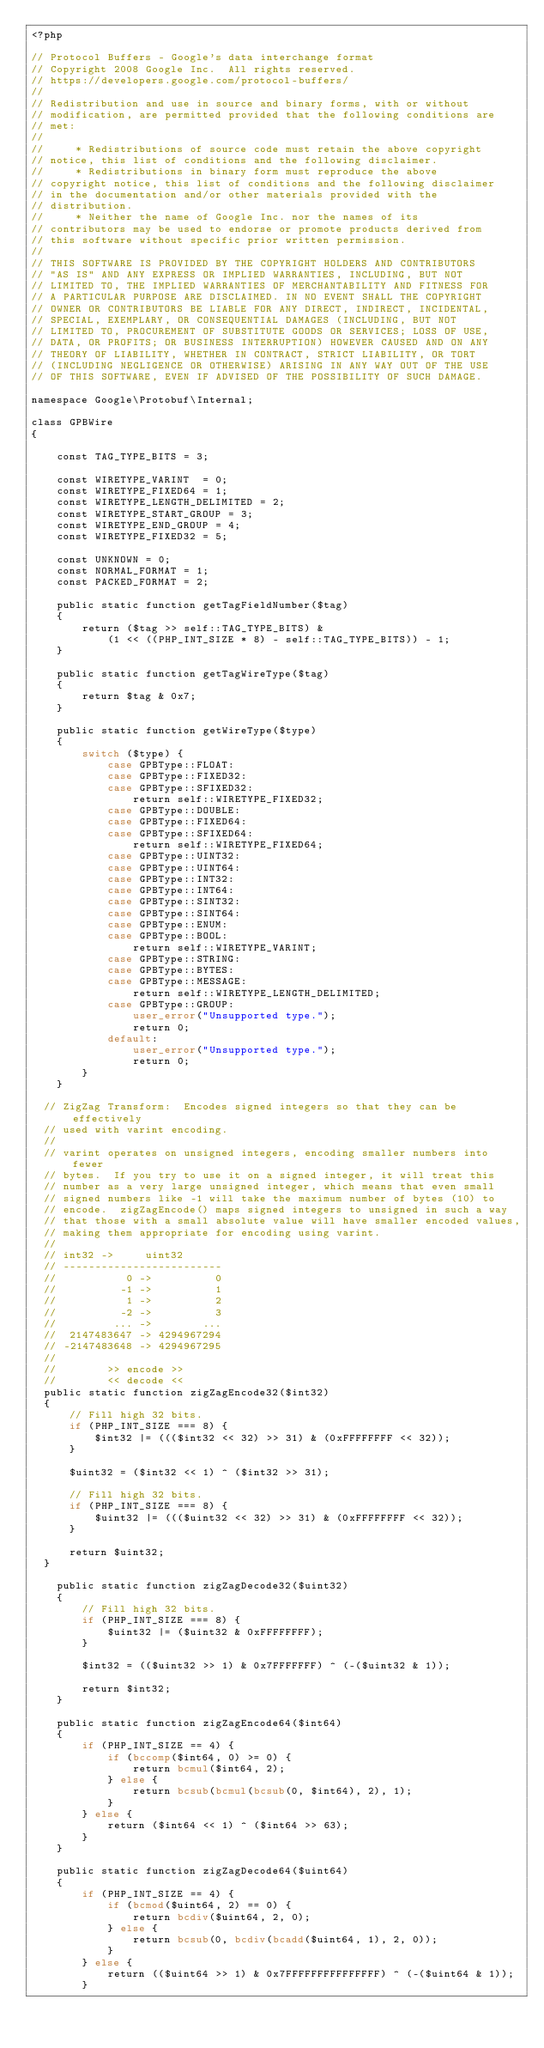Convert code to text. <code><loc_0><loc_0><loc_500><loc_500><_PHP_><?php

// Protocol Buffers - Google's data interchange format
// Copyright 2008 Google Inc.  All rights reserved.
// https://developers.google.com/protocol-buffers/
//
// Redistribution and use in source and binary forms, with or without
// modification, are permitted provided that the following conditions are
// met:
//
//     * Redistributions of source code must retain the above copyright
// notice, this list of conditions and the following disclaimer.
//     * Redistributions in binary form must reproduce the above
// copyright notice, this list of conditions and the following disclaimer
// in the documentation and/or other materials provided with the
// distribution.
//     * Neither the name of Google Inc. nor the names of its
// contributors may be used to endorse or promote products derived from
// this software without specific prior written permission.
//
// THIS SOFTWARE IS PROVIDED BY THE COPYRIGHT HOLDERS AND CONTRIBUTORS
// "AS IS" AND ANY EXPRESS OR IMPLIED WARRANTIES, INCLUDING, BUT NOT
// LIMITED TO, THE IMPLIED WARRANTIES OF MERCHANTABILITY AND FITNESS FOR
// A PARTICULAR PURPOSE ARE DISCLAIMED. IN NO EVENT SHALL THE COPYRIGHT
// OWNER OR CONTRIBUTORS BE LIABLE FOR ANY DIRECT, INDIRECT, INCIDENTAL,
// SPECIAL, EXEMPLARY, OR CONSEQUENTIAL DAMAGES (INCLUDING, BUT NOT
// LIMITED TO, PROCUREMENT OF SUBSTITUTE GOODS OR SERVICES; LOSS OF USE,
// DATA, OR PROFITS; OR BUSINESS INTERRUPTION) HOWEVER CAUSED AND ON ANY
// THEORY OF LIABILITY, WHETHER IN CONTRACT, STRICT LIABILITY, OR TORT
// (INCLUDING NEGLIGENCE OR OTHERWISE) ARISING IN ANY WAY OUT OF THE USE
// OF THIS SOFTWARE, EVEN IF ADVISED OF THE POSSIBILITY OF SUCH DAMAGE.

namespace Google\Protobuf\Internal;

class GPBWire
{

    const TAG_TYPE_BITS = 3;

    const WIRETYPE_VARINT  = 0;
    const WIRETYPE_FIXED64 = 1;
    const WIRETYPE_LENGTH_DELIMITED = 2;
    const WIRETYPE_START_GROUP = 3;
    const WIRETYPE_END_GROUP = 4;
    const WIRETYPE_FIXED32 = 5;

    const UNKNOWN = 0;
    const NORMAL_FORMAT = 1;
    const PACKED_FORMAT = 2;

    public static function getTagFieldNumber($tag)
    {
        return ($tag >> self::TAG_TYPE_BITS) &
            (1 << ((PHP_INT_SIZE * 8) - self::TAG_TYPE_BITS)) - 1;
    }

    public static function getTagWireType($tag)
    {
        return $tag & 0x7;
    }

    public static function getWireType($type)
    {
        switch ($type) {
            case GPBType::FLOAT:
            case GPBType::FIXED32:
            case GPBType::SFIXED32:
                return self::WIRETYPE_FIXED32;
            case GPBType::DOUBLE:
            case GPBType::FIXED64:
            case GPBType::SFIXED64:
                return self::WIRETYPE_FIXED64;
            case GPBType::UINT32:
            case GPBType::UINT64:
            case GPBType::INT32:
            case GPBType::INT64:
            case GPBType::SINT32:
            case GPBType::SINT64:
            case GPBType::ENUM:
            case GPBType::BOOL:
                return self::WIRETYPE_VARINT;
            case GPBType::STRING:
            case GPBType::BYTES:
            case GPBType::MESSAGE:
                return self::WIRETYPE_LENGTH_DELIMITED;
            case GPBType::GROUP:
                user_error("Unsupported type.");
                return 0;
            default:
                user_error("Unsupported type.");
                return 0;
        }
    }

  // ZigZag Transform:  Encodes signed integers so that they can be effectively
  // used with varint encoding.
  //
  // varint operates on unsigned integers, encoding smaller numbers into fewer
  // bytes.  If you try to use it on a signed integer, it will treat this
  // number as a very large unsigned integer, which means that even small
  // signed numbers like -1 will take the maximum number of bytes (10) to
  // encode.  zigZagEncode() maps signed integers to unsigned in such a way
  // that those with a small absolute value will have smaller encoded values,
  // making them appropriate for encoding using varint.
  //
  // int32 ->     uint32
  // -------------------------
  //           0 ->          0
  //          -1 ->          1
  //           1 ->          2
  //          -2 ->          3
  //         ... ->        ...
  //  2147483647 -> 4294967294
  // -2147483648 -> 4294967295
  //
  //        >> encode >>
  //        << decode <<
  public static function zigZagEncode32($int32)
  {
      // Fill high 32 bits.
      if (PHP_INT_SIZE === 8) {
          $int32 |= ((($int32 << 32) >> 31) & (0xFFFFFFFF << 32));
      }

      $uint32 = ($int32 << 1) ^ ($int32 >> 31);

      // Fill high 32 bits.
      if (PHP_INT_SIZE === 8) {
          $uint32 |= ((($uint32 << 32) >> 31) & (0xFFFFFFFF << 32));
      }

      return $uint32;
  }

    public static function zigZagDecode32($uint32)
    {
        // Fill high 32 bits.
        if (PHP_INT_SIZE === 8) {
            $uint32 |= ($uint32 & 0xFFFFFFFF);
        }

        $int32 = (($uint32 >> 1) & 0x7FFFFFFF) ^ (-($uint32 & 1));

        return $int32;
    }

    public static function zigZagEncode64($int64)
    {
        if (PHP_INT_SIZE == 4) {
            if (bccomp($int64, 0) >= 0) {
                return bcmul($int64, 2);
            } else {
                return bcsub(bcmul(bcsub(0, $int64), 2), 1);
            }
        } else {
            return ($int64 << 1) ^ ($int64 >> 63);
        }
    }

    public static function zigZagDecode64($uint64)
    {
        if (PHP_INT_SIZE == 4) {
            if (bcmod($uint64, 2) == 0) {
                return bcdiv($uint64, 2, 0);
            } else {
                return bcsub(0, bcdiv(bcadd($uint64, 1), 2, 0));
            }
        } else {
            return (($uint64 >> 1) & 0x7FFFFFFFFFFFFFFF) ^ (-($uint64 & 1));
        }</code> 